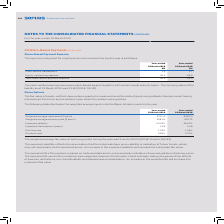According to Sophos Group's financial document, What was the carrying value of the liability in 2019? According to the financial document, $1.6M. The relevant text states: "ing value of the liability as at 31 March 2019 was $1.6M (2018: $3.1M)...." Also, What was the  Cash-settled transactions for 2019? According to the financial document, 1.9 (in millions). The relevant text states: "Cash-settled transactions 1.9 2.7..." Also, What are the types of transactions factored in the calculation of the total share-based payment expense recognised for employee services received during the year? The document shows two values: Cash-settled transactions and Equity-settled transactions. From the document: "Cash-settled transactions 1.9 2.7 Equity-settled transactions 35.0 39.6..." Additionally, In which year was the Cash-settled transactions larger? According to the financial document, 2018. The relevant text states: "Year-ended 31 March 2019 Year-ended 31 March 2018..." Also, can you calculate: What was the change in Cash-settled transactions in 2019 from 2018? Based on the calculation: 1.9-2.7, the result is -0.8 (in millions). This is based on the information: "Cash-settled transactions 1.9 2.7 Cash-settled transactions 1.9 2.7..." The key data points involved are: 1.9, 2.7. Also, can you calculate: What was the percentage change in Cash-settled transactions in 2019 from 2018? To answer this question, I need to perform calculations using the financial data. The calculation is: (1.9-2.7)/2.7, which equals -29.63 (percentage). This is based on the information: "Cash-settled transactions 1.9 2.7 Cash-settled transactions 1.9 2.7..." The key data points involved are: 1.9, 2.7. 